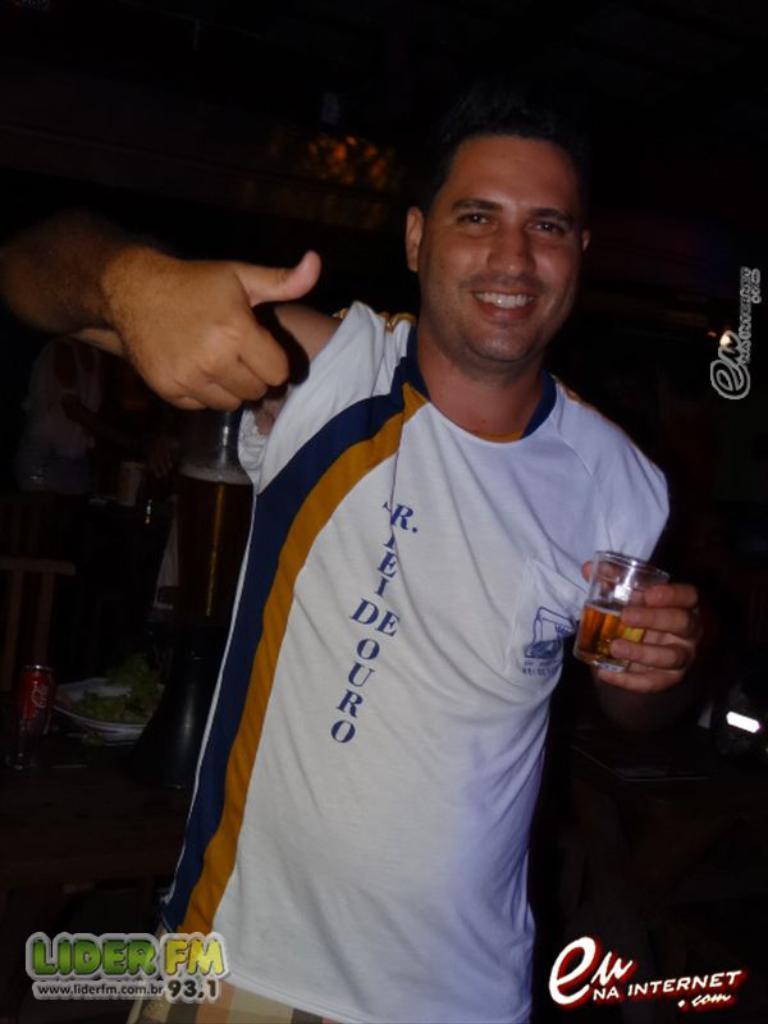Please provide a concise description of this image. In this image there is a man standing by holding a glass in his hand , and in the back ground there are group of people standing. 